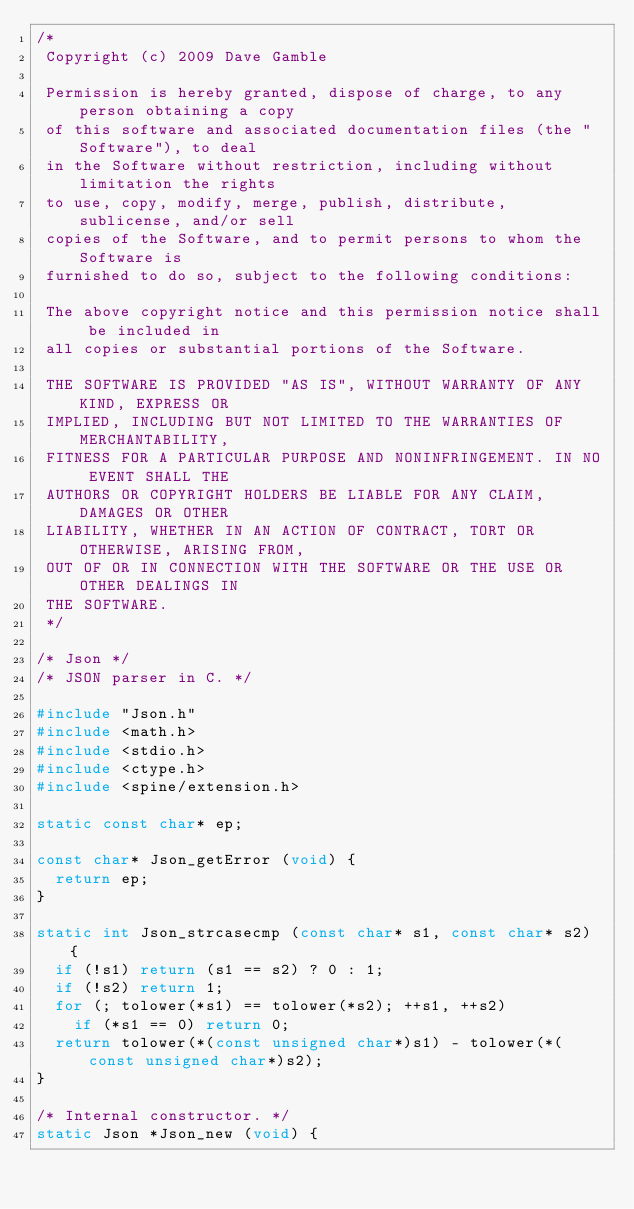Convert code to text. <code><loc_0><loc_0><loc_500><loc_500><_C++_>/*
 Copyright (c) 2009 Dave Gamble

 Permission is hereby granted, dispose of charge, to any person obtaining a copy
 of this software and associated documentation files (the "Software"), to deal
 in the Software without restriction, including without limitation the rights
 to use, copy, modify, merge, publish, distribute, sublicense, and/or sell
 copies of the Software, and to permit persons to whom the Software is
 furnished to do so, subject to the following conditions:

 The above copyright notice and this permission notice shall be included in
 all copies or substantial portions of the Software.

 THE SOFTWARE IS PROVIDED "AS IS", WITHOUT WARRANTY OF ANY KIND, EXPRESS OR
 IMPLIED, INCLUDING BUT NOT LIMITED TO THE WARRANTIES OF MERCHANTABILITY,
 FITNESS FOR A PARTICULAR PURPOSE AND NONINFRINGEMENT. IN NO EVENT SHALL THE
 AUTHORS OR COPYRIGHT HOLDERS BE LIABLE FOR ANY CLAIM, DAMAGES OR OTHER
 LIABILITY, WHETHER IN AN ACTION OF CONTRACT, TORT OR OTHERWISE, ARISING FROM,
 OUT OF OR IN CONNECTION WITH THE SOFTWARE OR THE USE OR OTHER DEALINGS IN
 THE SOFTWARE.
 */

/* Json */
/* JSON parser in C. */

#include "Json.h"
#include <math.h>
#include <stdio.h>
#include <ctype.h>
#include <spine/extension.h>

static const char* ep;

const char* Json_getError (void) {
	return ep;
}

static int Json_strcasecmp (const char* s1, const char* s2) {
	if (!s1) return (s1 == s2) ? 0 : 1;
	if (!s2) return 1;
	for (; tolower(*s1) == tolower(*s2); ++s1, ++s2)
		if (*s1 == 0) return 0;
	return tolower(*(const unsigned char*)s1) - tolower(*(const unsigned char*)s2);
}

/* Internal constructor. */
static Json *Json_new (void) {</code> 